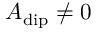<formula> <loc_0><loc_0><loc_500><loc_500>A _ { d i p } \neq 0</formula> 